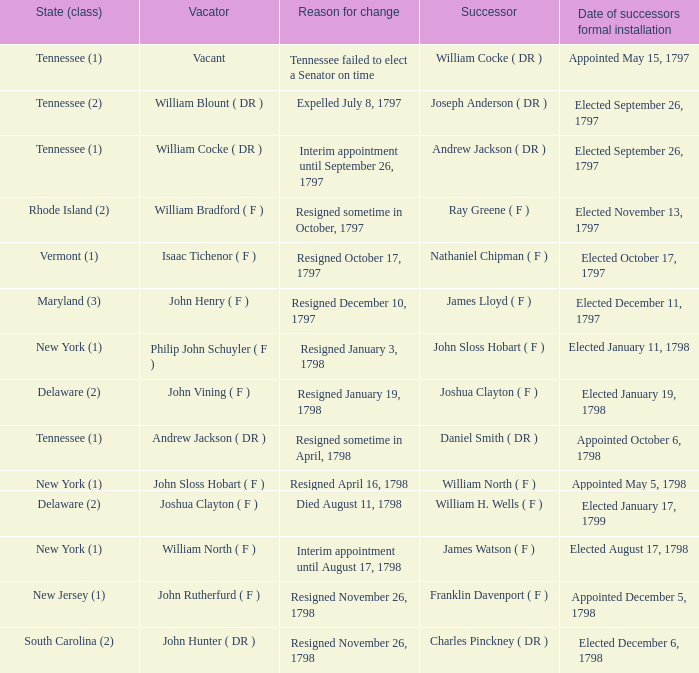What are the various states (class) when the cause for alteration was resignation on november 26, 1798, and the person vacating was john hunter (dr)? South Carolina (2). 